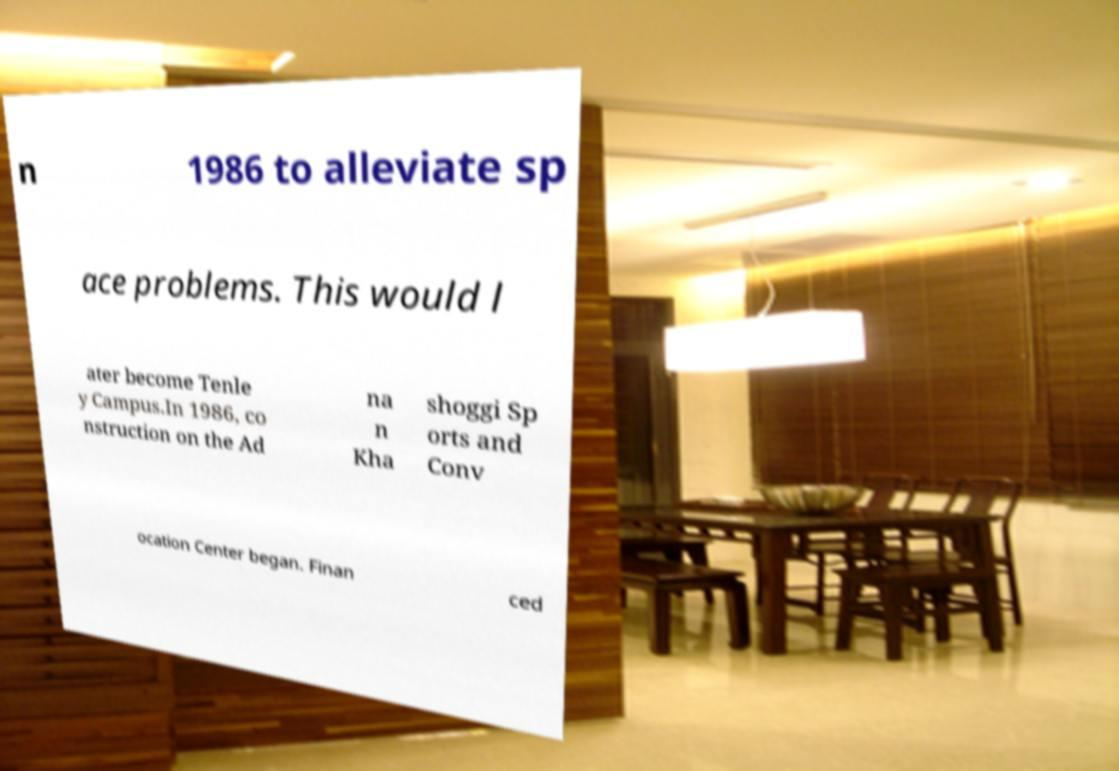Could you extract and type out the text from this image? n 1986 to alleviate sp ace problems. This would l ater become Tenle y Campus.In 1986, co nstruction on the Ad na n Kha shoggi Sp orts and Conv ocation Center began. Finan ced 